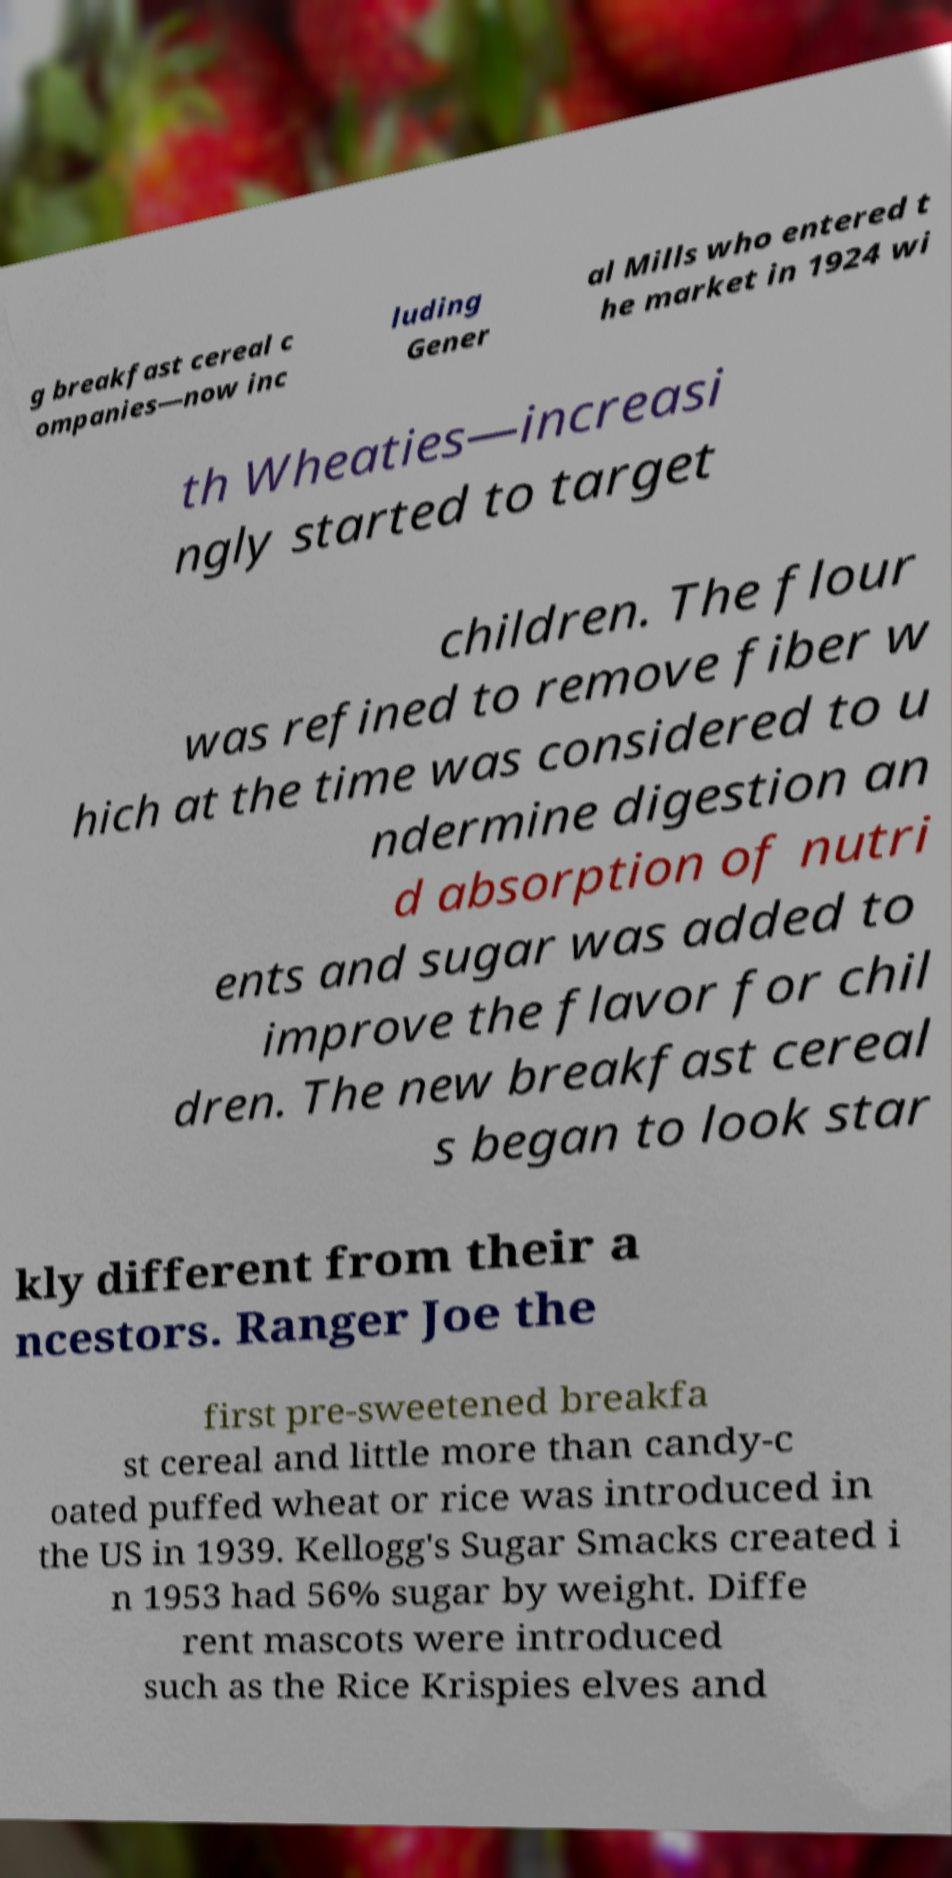For documentation purposes, I need the text within this image transcribed. Could you provide that? g breakfast cereal c ompanies—now inc luding Gener al Mills who entered t he market in 1924 wi th Wheaties—increasi ngly started to target children. The flour was refined to remove fiber w hich at the time was considered to u ndermine digestion an d absorption of nutri ents and sugar was added to improve the flavor for chil dren. The new breakfast cereal s began to look star kly different from their a ncestors. Ranger Joe the first pre-sweetened breakfa st cereal and little more than candy-c oated puffed wheat or rice was introduced in the US in 1939. Kellogg's Sugar Smacks created i n 1953 had 56% sugar by weight. Diffe rent mascots were introduced such as the Rice Krispies elves and 